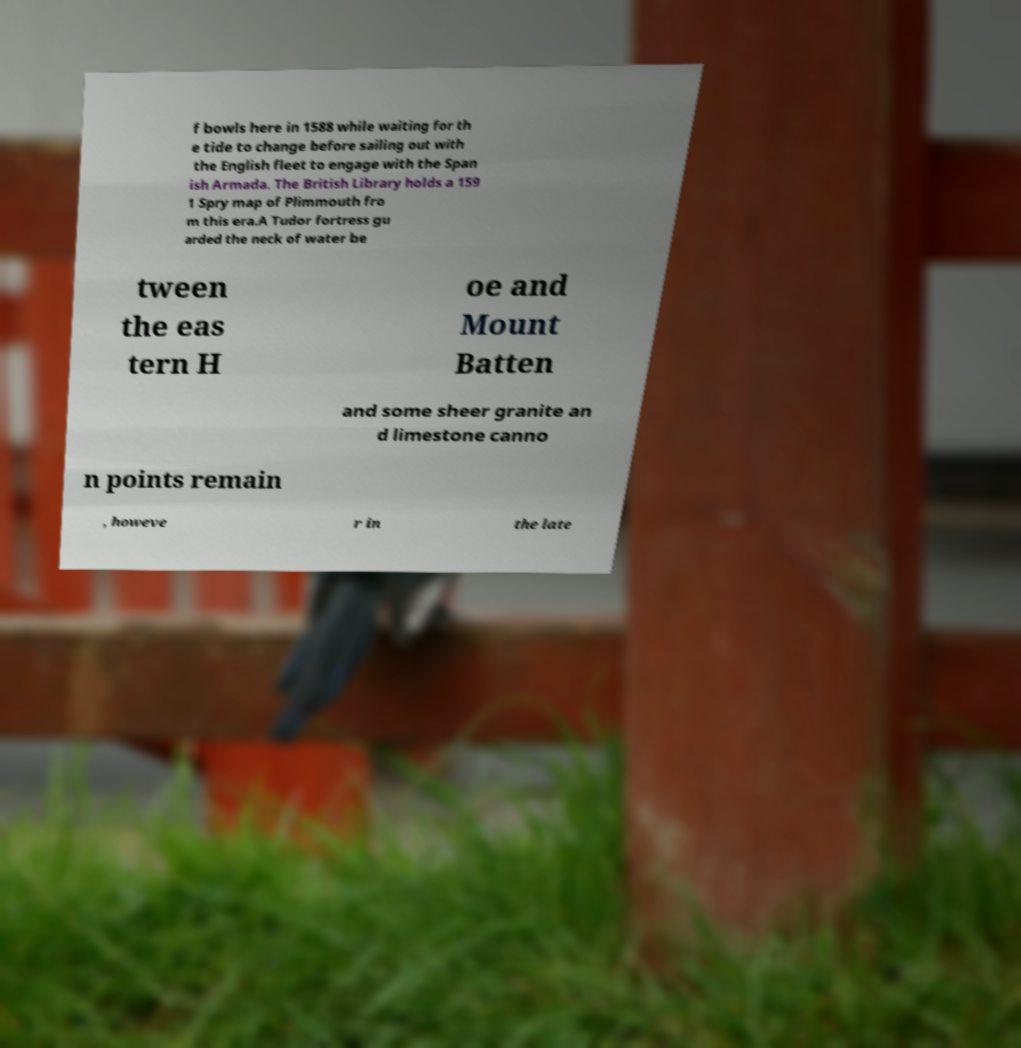What messages or text are displayed in this image? I need them in a readable, typed format. f bowls here in 1588 while waiting for th e tide to change before sailing out with the English fleet to engage with the Span ish Armada. The British Library holds a 159 1 Spry map of Plimmouth fro m this era.A Tudor fortress gu arded the neck of water be tween the eas tern H oe and Mount Batten and some sheer granite an d limestone canno n points remain , howeve r in the late 